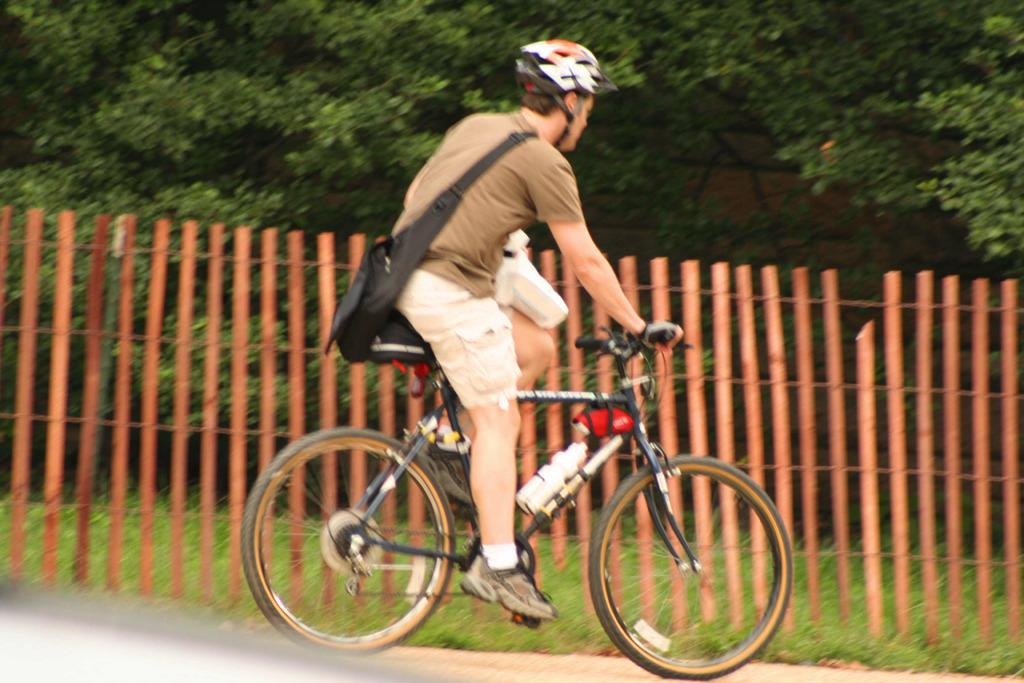What is the person in the image doing? The person is riding a bicycle. What safety gear is the person wearing? The person is wearing a helmet. What additional item is the person carrying? The person is carrying a backpack. What type of path is the person riding on? There is a road in the image. What can be seen in the background of the image? There are trees and a fencing in the background of the image. Can you see a hole in the person's arm in the image? There is no hole visible in the person's arm in the image. Are the person and another individual sharing a kiss in the image? There is no kissing depicted in the image; the person is riding a bicycle. 